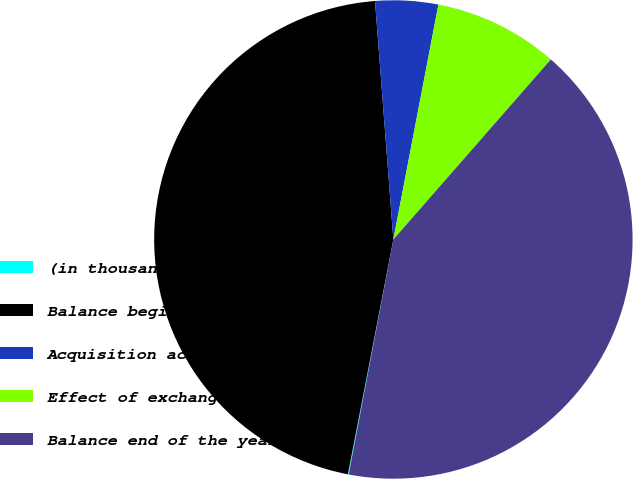Convert chart. <chart><loc_0><loc_0><loc_500><loc_500><pie_chart><fcel>(in thousands)<fcel>Balance beginning of the year<fcel>Acquisition activity<fcel>Effect of exchange rate<fcel>Balance end of the year<nl><fcel>0.06%<fcel>45.73%<fcel>4.24%<fcel>8.42%<fcel>41.55%<nl></chart> 